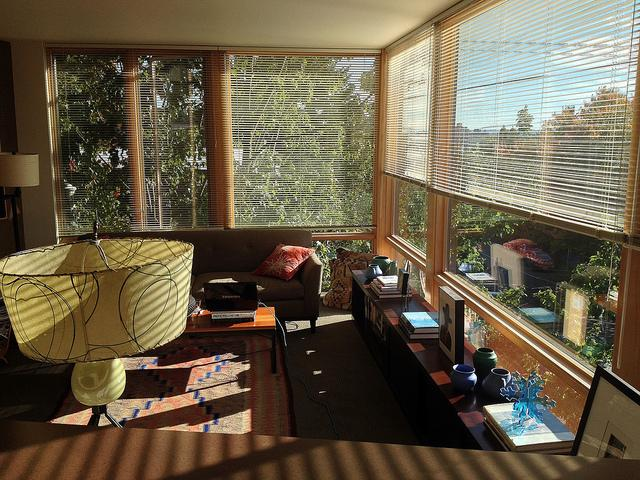How many items in the living room may have to share an outlet with the laptop? two 